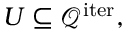<formula> <loc_0><loc_0><loc_500><loc_500>U \subseteq \mathcal { Q } ^ { i t e r } ,</formula> 